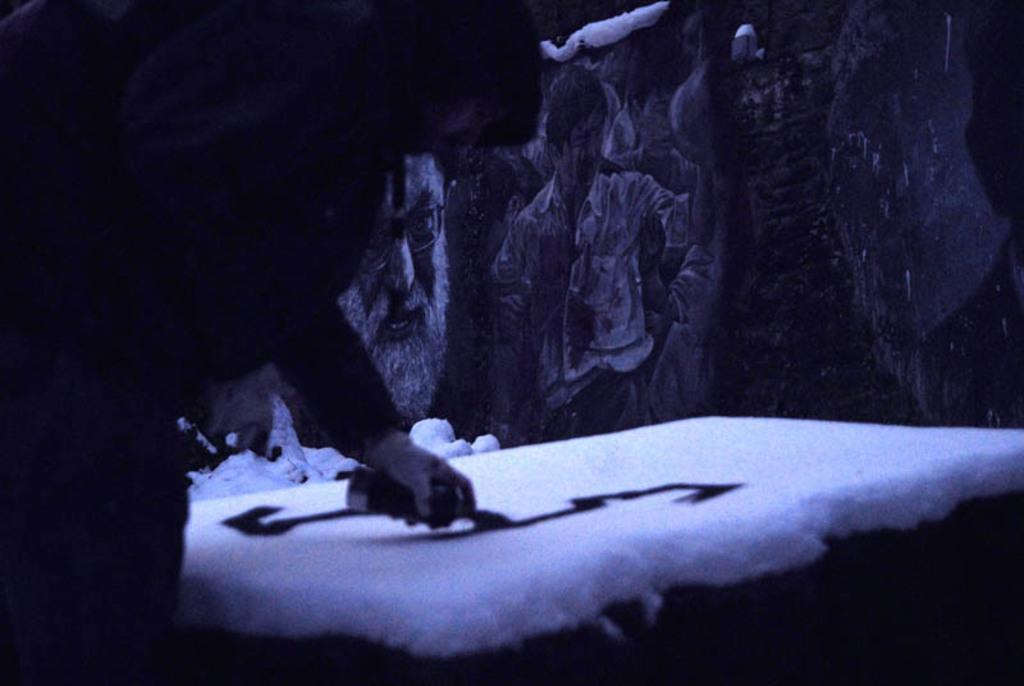What is the person in the image holding? The person is holding an object in the image. What is the object placed on? The object appears to be placed on ice. What can be seen in the background of the image? There are sketches in the background of the image. How many bears are visible in the image? There are no bears present in the image. What type of roll is being used by the person in the image? There is no roll visible in the image; the person is holding an object placed on ice. 